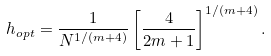<formula> <loc_0><loc_0><loc_500><loc_500>h _ { o p t } = \frac { 1 } { N ^ { 1 / ( m + 4 ) } } \left [ \frac { 4 } { 2 m + 1 } \right ] ^ { 1 / ( m + 4 ) } .</formula> 